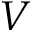<formula> <loc_0><loc_0><loc_500><loc_500>V</formula> 